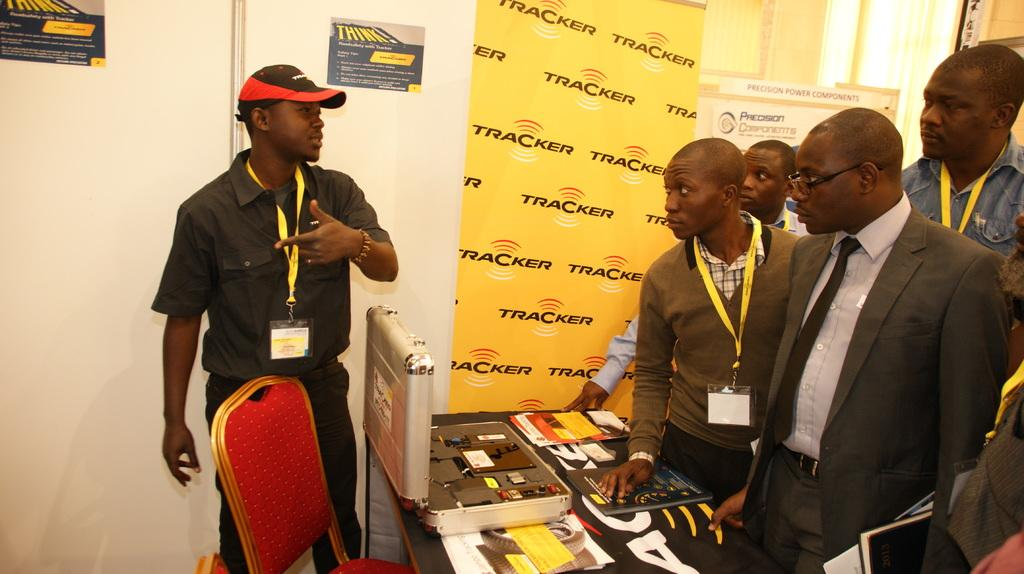How many people are in the image? There are persons in the image, but the exact number cannot be determined from the provided facts. What type of furniture is present in the image? There is a chair and a table in the image. What is on top of the table? There is a box and books on the table. What can be seen in the background of the image? There are posters and a wall in the background of the image. What type of moon can be seen in the image? There is no moon present in the image. What is the chicken doing in the image? There is no chicken present in the image. 